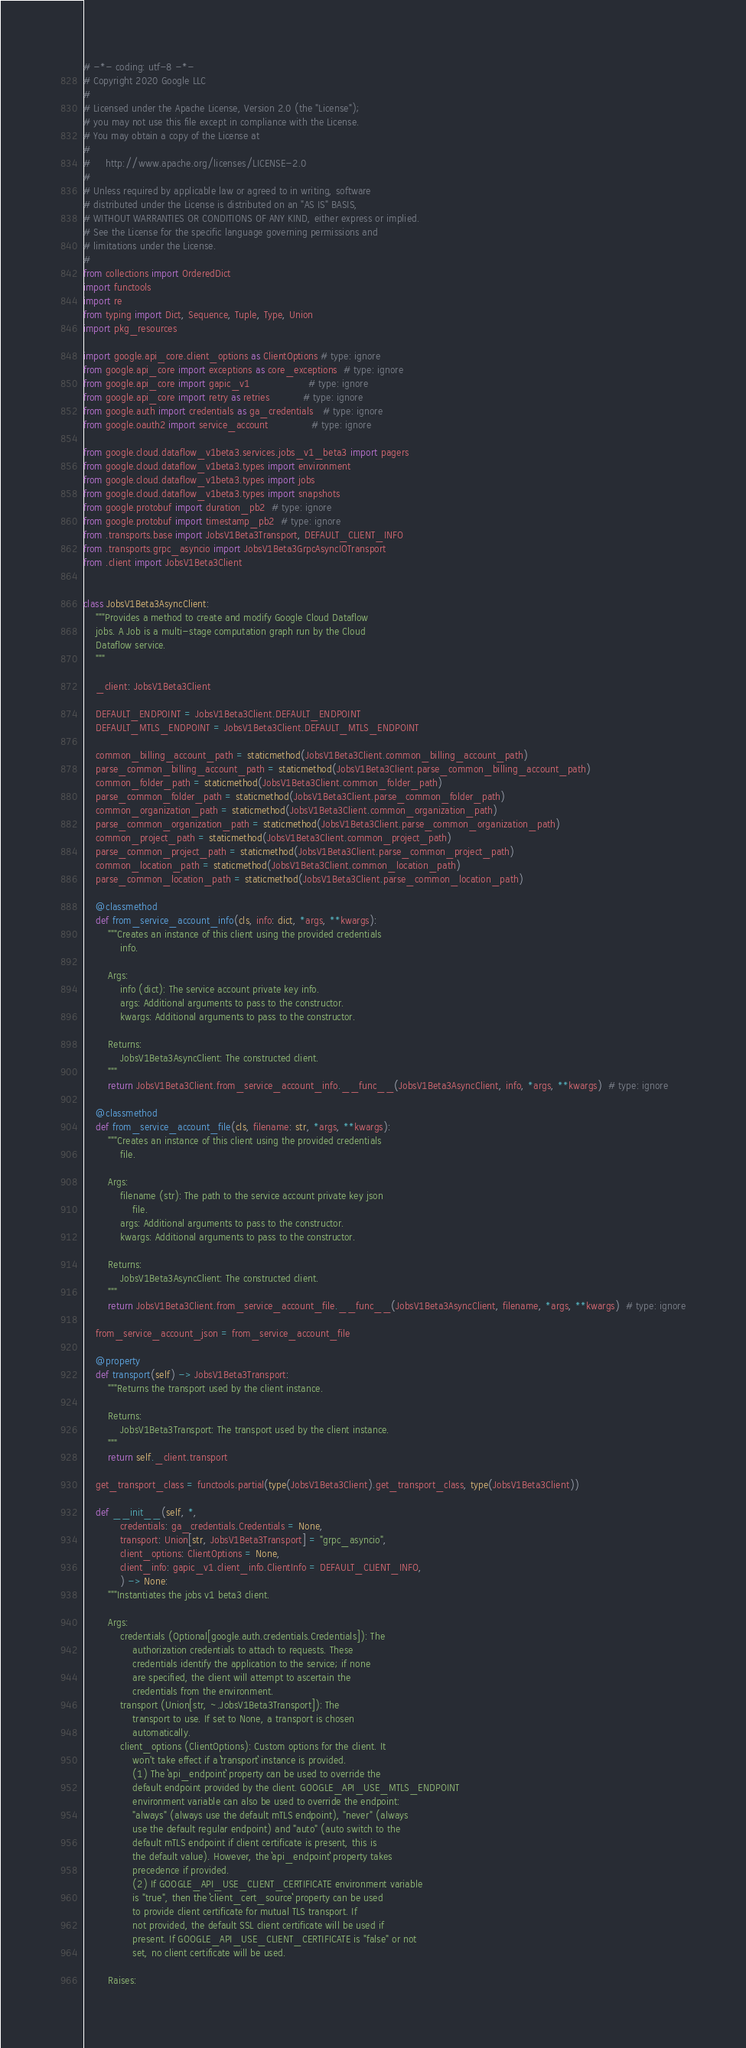<code> <loc_0><loc_0><loc_500><loc_500><_Python_># -*- coding: utf-8 -*-
# Copyright 2020 Google LLC
#
# Licensed under the Apache License, Version 2.0 (the "License");
# you may not use this file except in compliance with the License.
# You may obtain a copy of the License at
#
#     http://www.apache.org/licenses/LICENSE-2.0
#
# Unless required by applicable law or agreed to in writing, software
# distributed under the License is distributed on an "AS IS" BASIS,
# WITHOUT WARRANTIES OR CONDITIONS OF ANY KIND, either express or implied.
# See the License for the specific language governing permissions and
# limitations under the License.
#
from collections import OrderedDict
import functools
import re
from typing import Dict, Sequence, Tuple, Type, Union
import pkg_resources

import google.api_core.client_options as ClientOptions # type: ignore
from google.api_core import exceptions as core_exceptions  # type: ignore
from google.api_core import gapic_v1                   # type: ignore
from google.api_core import retry as retries           # type: ignore
from google.auth import credentials as ga_credentials   # type: ignore
from google.oauth2 import service_account              # type: ignore

from google.cloud.dataflow_v1beta3.services.jobs_v1_beta3 import pagers
from google.cloud.dataflow_v1beta3.types import environment
from google.cloud.dataflow_v1beta3.types import jobs
from google.cloud.dataflow_v1beta3.types import snapshots
from google.protobuf import duration_pb2  # type: ignore
from google.protobuf import timestamp_pb2  # type: ignore
from .transports.base import JobsV1Beta3Transport, DEFAULT_CLIENT_INFO
from .transports.grpc_asyncio import JobsV1Beta3GrpcAsyncIOTransport
from .client import JobsV1Beta3Client


class JobsV1Beta3AsyncClient:
    """Provides a method to create and modify Google Cloud Dataflow
    jobs. A Job is a multi-stage computation graph run by the Cloud
    Dataflow service.
    """

    _client: JobsV1Beta3Client

    DEFAULT_ENDPOINT = JobsV1Beta3Client.DEFAULT_ENDPOINT
    DEFAULT_MTLS_ENDPOINT = JobsV1Beta3Client.DEFAULT_MTLS_ENDPOINT

    common_billing_account_path = staticmethod(JobsV1Beta3Client.common_billing_account_path)
    parse_common_billing_account_path = staticmethod(JobsV1Beta3Client.parse_common_billing_account_path)
    common_folder_path = staticmethod(JobsV1Beta3Client.common_folder_path)
    parse_common_folder_path = staticmethod(JobsV1Beta3Client.parse_common_folder_path)
    common_organization_path = staticmethod(JobsV1Beta3Client.common_organization_path)
    parse_common_organization_path = staticmethod(JobsV1Beta3Client.parse_common_organization_path)
    common_project_path = staticmethod(JobsV1Beta3Client.common_project_path)
    parse_common_project_path = staticmethod(JobsV1Beta3Client.parse_common_project_path)
    common_location_path = staticmethod(JobsV1Beta3Client.common_location_path)
    parse_common_location_path = staticmethod(JobsV1Beta3Client.parse_common_location_path)

    @classmethod
    def from_service_account_info(cls, info: dict, *args, **kwargs):
        """Creates an instance of this client using the provided credentials
            info.

        Args:
            info (dict): The service account private key info.
            args: Additional arguments to pass to the constructor.
            kwargs: Additional arguments to pass to the constructor.

        Returns:
            JobsV1Beta3AsyncClient: The constructed client.
        """
        return JobsV1Beta3Client.from_service_account_info.__func__(JobsV1Beta3AsyncClient, info, *args, **kwargs)  # type: ignore

    @classmethod
    def from_service_account_file(cls, filename: str, *args, **kwargs):
        """Creates an instance of this client using the provided credentials
            file.

        Args:
            filename (str): The path to the service account private key json
                file.
            args: Additional arguments to pass to the constructor.
            kwargs: Additional arguments to pass to the constructor.

        Returns:
            JobsV1Beta3AsyncClient: The constructed client.
        """
        return JobsV1Beta3Client.from_service_account_file.__func__(JobsV1Beta3AsyncClient, filename, *args, **kwargs)  # type: ignore

    from_service_account_json = from_service_account_file

    @property
    def transport(self) -> JobsV1Beta3Transport:
        """Returns the transport used by the client instance.

        Returns:
            JobsV1Beta3Transport: The transport used by the client instance.
        """
        return self._client.transport

    get_transport_class = functools.partial(type(JobsV1Beta3Client).get_transport_class, type(JobsV1Beta3Client))

    def __init__(self, *,
            credentials: ga_credentials.Credentials = None,
            transport: Union[str, JobsV1Beta3Transport] = "grpc_asyncio",
            client_options: ClientOptions = None,
            client_info: gapic_v1.client_info.ClientInfo = DEFAULT_CLIENT_INFO,
            ) -> None:
        """Instantiates the jobs v1 beta3 client.

        Args:
            credentials (Optional[google.auth.credentials.Credentials]): The
                authorization credentials to attach to requests. These
                credentials identify the application to the service; if none
                are specified, the client will attempt to ascertain the
                credentials from the environment.
            transport (Union[str, ~.JobsV1Beta3Transport]): The
                transport to use. If set to None, a transport is chosen
                automatically.
            client_options (ClientOptions): Custom options for the client. It
                won't take effect if a ``transport`` instance is provided.
                (1) The ``api_endpoint`` property can be used to override the
                default endpoint provided by the client. GOOGLE_API_USE_MTLS_ENDPOINT
                environment variable can also be used to override the endpoint:
                "always" (always use the default mTLS endpoint), "never" (always
                use the default regular endpoint) and "auto" (auto switch to the
                default mTLS endpoint if client certificate is present, this is
                the default value). However, the ``api_endpoint`` property takes
                precedence if provided.
                (2) If GOOGLE_API_USE_CLIENT_CERTIFICATE environment variable
                is "true", then the ``client_cert_source`` property can be used
                to provide client certificate for mutual TLS transport. If
                not provided, the default SSL client certificate will be used if
                present. If GOOGLE_API_USE_CLIENT_CERTIFICATE is "false" or not
                set, no client certificate will be used.

        Raises:</code> 